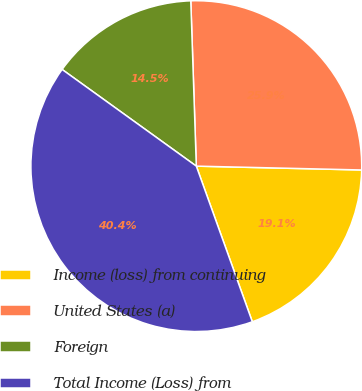Convert chart to OTSL. <chart><loc_0><loc_0><loc_500><loc_500><pie_chart><fcel>Income (loss) from continuing<fcel>United States (a)<fcel>Foreign<fcel>Total Income (Loss) from<nl><fcel>19.13%<fcel>25.9%<fcel>14.53%<fcel>40.43%<nl></chart> 